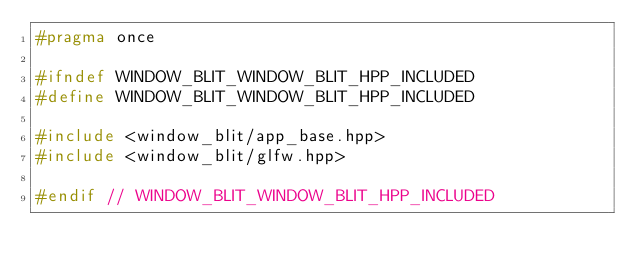<code> <loc_0><loc_0><loc_500><loc_500><_C++_>#pragma once

#ifndef WINDOW_BLIT_WINDOW_BLIT_HPP_INCLUDED
#define WINDOW_BLIT_WINDOW_BLIT_HPP_INCLUDED

#include <window_blit/app_base.hpp>
#include <window_blit/glfw.hpp>

#endif // WINDOW_BLIT_WINDOW_BLIT_HPP_INCLUDED
</code> 